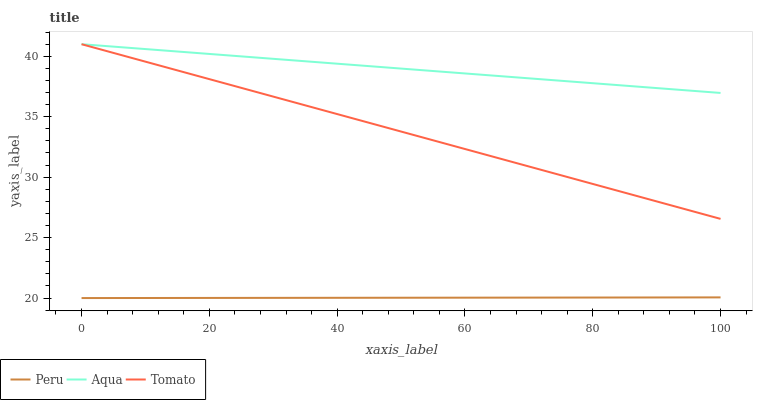Does Aqua have the minimum area under the curve?
Answer yes or no. No. Does Peru have the maximum area under the curve?
Answer yes or no. No. Is Aqua the smoothest?
Answer yes or no. No. Is Peru the roughest?
Answer yes or no. No. Does Aqua have the lowest value?
Answer yes or no. No. Does Peru have the highest value?
Answer yes or no. No. Is Peru less than Tomato?
Answer yes or no. Yes. Is Aqua greater than Peru?
Answer yes or no. Yes. Does Peru intersect Tomato?
Answer yes or no. No. 